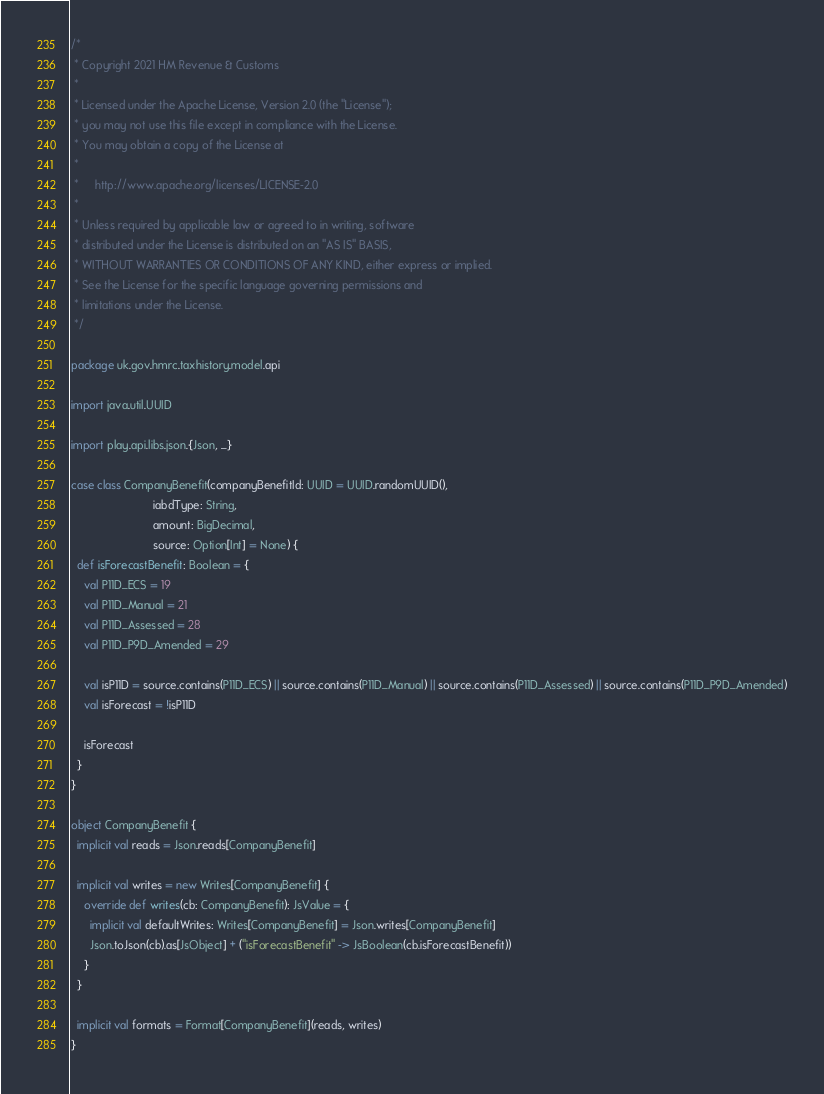Convert code to text. <code><loc_0><loc_0><loc_500><loc_500><_Scala_>/*
 * Copyright 2021 HM Revenue & Customs
 *
 * Licensed under the Apache License, Version 2.0 (the "License");
 * you may not use this file except in compliance with the License.
 * You may obtain a copy of the License at
 *
 *     http://www.apache.org/licenses/LICENSE-2.0
 *
 * Unless required by applicable law or agreed to in writing, software
 * distributed under the License is distributed on an "AS IS" BASIS,
 * WITHOUT WARRANTIES OR CONDITIONS OF ANY KIND, either express or implied.
 * See the License for the specific language governing permissions and
 * limitations under the License.
 */

package uk.gov.hmrc.taxhistory.model.api

import java.util.UUID

import play.api.libs.json.{Json, _}

case class CompanyBenefit(companyBenefitId: UUID = UUID.randomUUID(),
                          iabdType: String,
                          amount: BigDecimal,
                          source: Option[Int] = None) {
  def isForecastBenefit: Boolean = {
    val P11D_ECS = 19
    val P11D_Manual = 21
    val P11D_Assessed = 28
    val P11D_P9D_Amended = 29

    val isP11D = source.contains(P11D_ECS) || source.contains(P11D_Manual) || source.contains(P11D_Assessed) || source.contains(P11D_P9D_Amended)
    val isForecast = !isP11D

    isForecast
  }
}

object CompanyBenefit {
  implicit val reads = Json.reads[CompanyBenefit]

  implicit val writes = new Writes[CompanyBenefit] {
    override def writes(cb: CompanyBenefit): JsValue = {
      implicit val defaultWrites: Writes[CompanyBenefit] = Json.writes[CompanyBenefit]
      Json.toJson(cb).as[JsObject] + ("isForecastBenefit" -> JsBoolean(cb.isForecastBenefit))
    }
  }

  implicit val formats = Format[CompanyBenefit](reads, writes)
}
</code> 